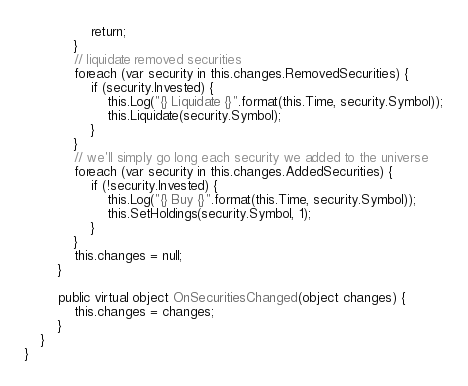Convert code to text. <code><loc_0><loc_0><loc_500><loc_500><_C#_>                return;
            }
            // liquidate removed securities
            foreach (var security in this.changes.RemovedSecurities) {
                if (security.Invested) {
                    this.Log("{} Liquidate {}".format(this.Time, security.Symbol));
                    this.Liquidate(security.Symbol);
                }
            }
            // we'll simply go long each security we added to the universe
            foreach (var security in this.changes.AddedSecurities) {
                if (!security.Invested) {
                    this.Log("{} Buy {}".format(this.Time, security.Symbol));
                    this.SetHoldings(security.Symbol, 1);
                }
            }
            this.changes = null;
        }
        
        public virtual object OnSecuritiesChanged(object changes) {
            this.changes = changes;
        }
    }
}
</code> 